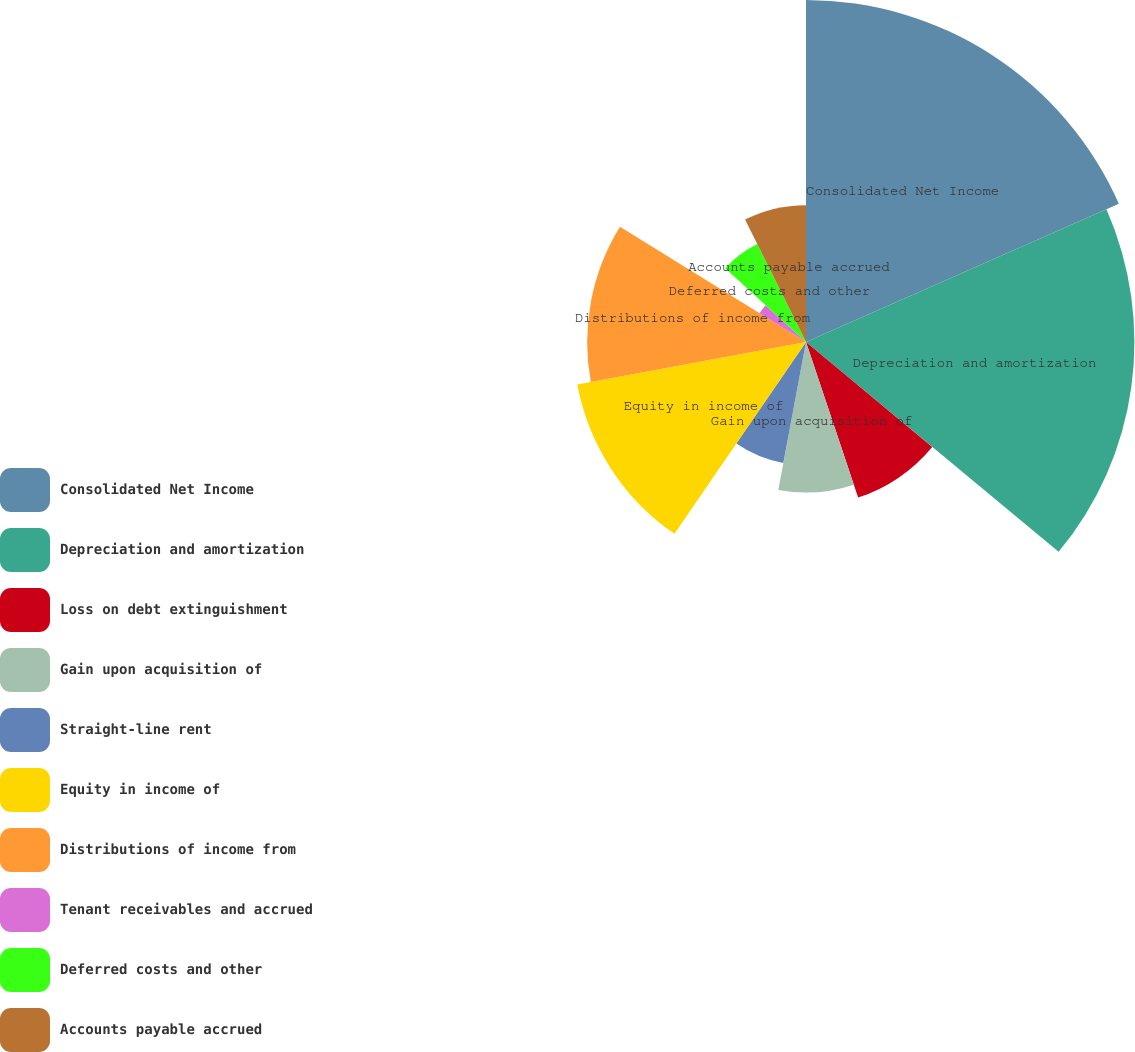Convert chart. <chart><loc_0><loc_0><loc_500><loc_500><pie_chart><fcel>Consolidated Net Income<fcel>Depreciation and amortization<fcel>Loss on debt extinguishment<fcel>Gain upon acquisition of<fcel>Straight-line rent<fcel>Equity in income of<fcel>Distributions of income from<fcel>Tenant receivables and accrued<fcel>Deferred costs and other<fcel>Accounts payable accrued<nl><fcel>18.38%<fcel>17.65%<fcel>8.82%<fcel>8.09%<fcel>6.62%<fcel>12.5%<fcel>11.76%<fcel>2.94%<fcel>5.88%<fcel>7.35%<nl></chart> 